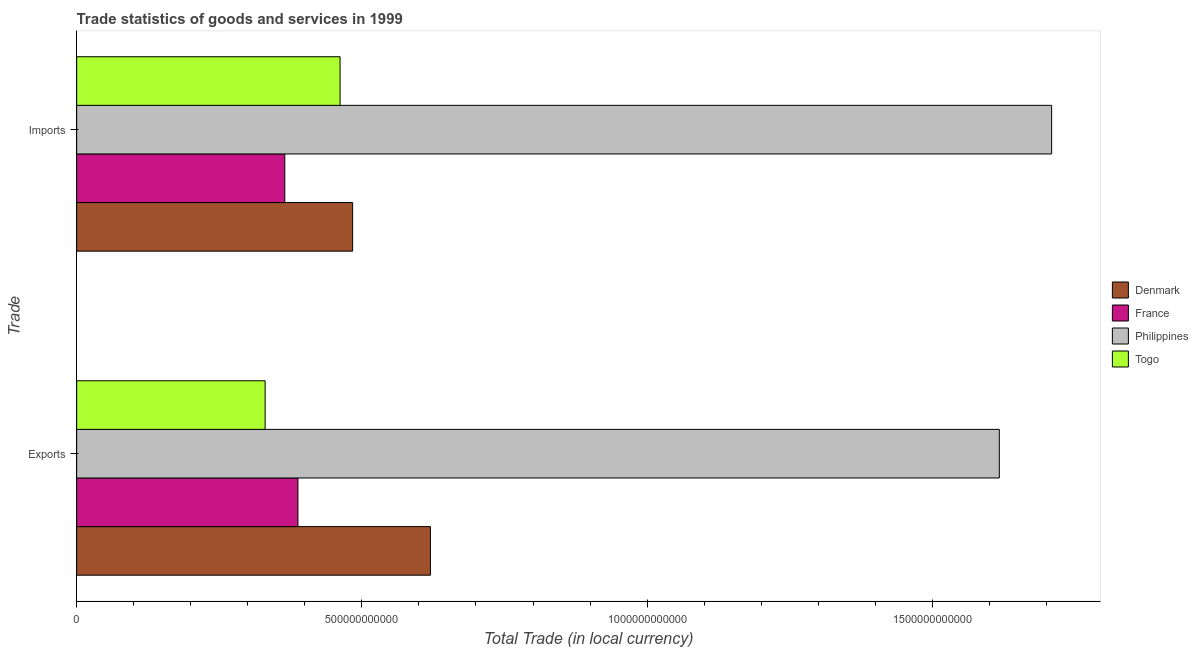Are the number of bars per tick equal to the number of legend labels?
Make the answer very short. Yes. What is the label of the 1st group of bars from the top?
Provide a succinct answer. Imports. What is the export of goods and services in Denmark?
Offer a very short reply. 6.20e+11. Across all countries, what is the maximum export of goods and services?
Provide a short and direct response. 1.62e+12. Across all countries, what is the minimum export of goods and services?
Offer a very short reply. 3.30e+11. In which country was the export of goods and services minimum?
Give a very brief answer. Togo. What is the total imports of goods and services in the graph?
Provide a short and direct response. 3.02e+12. What is the difference between the export of goods and services in Togo and that in Philippines?
Offer a terse response. -1.29e+12. What is the difference between the export of goods and services in Togo and the imports of goods and services in France?
Your response must be concise. -3.45e+1. What is the average export of goods and services per country?
Offer a very short reply. 7.39e+11. What is the difference between the export of goods and services and imports of goods and services in Philippines?
Your answer should be compact. -9.17e+1. In how many countries, is the export of goods and services greater than 800000000000 LCU?
Your answer should be compact. 1. What is the ratio of the imports of goods and services in Philippines to that in France?
Your answer should be very brief. 4.68. What does the 2nd bar from the top in Imports represents?
Offer a very short reply. Philippines. What does the 3rd bar from the bottom in Exports represents?
Give a very brief answer. Philippines. What is the difference between two consecutive major ticks on the X-axis?
Keep it short and to the point. 5.00e+11. Does the graph contain grids?
Make the answer very short. No. How are the legend labels stacked?
Give a very brief answer. Vertical. What is the title of the graph?
Provide a succinct answer. Trade statistics of goods and services in 1999. Does "Equatorial Guinea" appear as one of the legend labels in the graph?
Your answer should be very brief. No. What is the label or title of the X-axis?
Ensure brevity in your answer.  Total Trade (in local currency). What is the label or title of the Y-axis?
Your answer should be very brief. Trade. What is the Total Trade (in local currency) of Denmark in Exports?
Your answer should be very brief. 6.20e+11. What is the Total Trade (in local currency) in France in Exports?
Your response must be concise. 3.88e+11. What is the Total Trade (in local currency) in Philippines in Exports?
Give a very brief answer. 1.62e+12. What is the Total Trade (in local currency) in Togo in Exports?
Offer a terse response. 3.30e+11. What is the Total Trade (in local currency) of Denmark in Imports?
Make the answer very short. 4.84e+11. What is the Total Trade (in local currency) of France in Imports?
Provide a short and direct response. 3.65e+11. What is the Total Trade (in local currency) in Philippines in Imports?
Ensure brevity in your answer.  1.71e+12. What is the Total Trade (in local currency) of Togo in Imports?
Ensure brevity in your answer.  4.62e+11. Across all Trade, what is the maximum Total Trade (in local currency) of Denmark?
Ensure brevity in your answer.  6.20e+11. Across all Trade, what is the maximum Total Trade (in local currency) in France?
Give a very brief answer. 3.88e+11. Across all Trade, what is the maximum Total Trade (in local currency) in Philippines?
Your answer should be compact. 1.71e+12. Across all Trade, what is the maximum Total Trade (in local currency) of Togo?
Give a very brief answer. 4.62e+11. Across all Trade, what is the minimum Total Trade (in local currency) in Denmark?
Provide a succinct answer. 4.84e+11. Across all Trade, what is the minimum Total Trade (in local currency) in France?
Offer a very short reply. 3.65e+11. Across all Trade, what is the minimum Total Trade (in local currency) in Philippines?
Your answer should be very brief. 1.62e+12. Across all Trade, what is the minimum Total Trade (in local currency) in Togo?
Offer a very short reply. 3.30e+11. What is the total Total Trade (in local currency) of Denmark in the graph?
Offer a very short reply. 1.10e+12. What is the total Total Trade (in local currency) of France in the graph?
Provide a short and direct response. 7.53e+11. What is the total Total Trade (in local currency) in Philippines in the graph?
Make the answer very short. 3.33e+12. What is the total Total Trade (in local currency) in Togo in the graph?
Your answer should be compact. 7.92e+11. What is the difference between the Total Trade (in local currency) of Denmark in Exports and that in Imports?
Give a very brief answer. 1.36e+11. What is the difference between the Total Trade (in local currency) of France in Exports and that in Imports?
Provide a succinct answer. 2.30e+1. What is the difference between the Total Trade (in local currency) in Philippines in Exports and that in Imports?
Your response must be concise. -9.17e+1. What is the difference between the Total Trade (in local currency) in Togo in Exports and that in Imports?
Offer a terse response. -1.31e+11. What is the difference between the Total Trade (in local currency) of Denmark in Exports and the Total Trade (in local currency) of France in Imports?
Make the answer very short. 2.55e+11. What is the difference between the Total Trade (in local currency) of Denmark in Exports and the Total Trade (in local currency) of Philippines in Imports?
Ensure brevity in your answer.  -1.09e+12. What is the difference between the Total Trade (in local currency) of Denmark in Exports and the Total Trade (in local currency) of Togo in Imports?
Offer a very short reply. 1.58e+11. What is the difference between the Total Trade (in local currency) of France in Exports and the Total Trade (in local currency) of Philippines in Imports?
Provide a succinct answer. -1.32e+12. What is the difference between the Total Trade (in local currency) of France in Exports and the Total Trade (in local currency) of Togo in Imports?
Keep it short and to the point. -7.39e+1. What is the difference between the Total Trade (in local currency) of Philippines in Exports and the Total Trade (in local currency) of Togo in Imports?
Make the answer very short. 1.16e+12. What is the average Total Trade (in local currency) of Denmark per Trade?
Your response must be concise. 5.52e+11. What is the average Total Trade (in local currency) of France per Trade?
Keep it short and to the point. 3.76e+11. What is the average Total Trade (in local currency) in Philippines per Trade?
Offer a very short reply. 1.66e+12. What is the average Total Trade (in local currency) in Togo per Trade?
Ensure brevity in your answer.  3.96e+11. What is the difference between the Total Trade (in local currency) of Denmark and Total Trade (in local currency) of France in Exports?
Ensure brevity in your answer.  2.32e+11. What is the difference between the Total Trade (in local currency) of Denmark and Total Trade (in local currency) of Philippines in Exports?
Make the answer very short. -9.97e+11. What is the difference between the Total Trade (in local currency) in Denmark and Total Trade (in local currency) in Togo in Exports?
Make the answer very short. 2.90e+11. What is the difference between the Total Trade (in local currency) in France and Total Trade (in local currency) in Philippines in Exports?
Make the answer very short. -1.23e+12. What is the difference between the Total Trade (in local currency) of France and Total Trade (in local currency) of Togo in Exports?
Make the answer very short. 5.75e+1. What is the difference between the Total Trade (in local currency) of Philippines and Total Trade (in local currency) of Togo in Exports?
Keep it short and to the point. 1.29e+12. What is the difference between the Total Trade (in local currency) in Denmark and Total Trade (in local currency) in France in Imports?
Provide a short and direct response. 1.19e+11. What is the difference between the Total Trade (in local currency) in Denmark and Total Trade (in local currency) in Philippines in Imports?
Your answer should be compact. -1.23e+12. What is the difference between the Total Trade (in local currency) of Denmark and Total Trade (in local currency) of Togo in Imports?
Your answer should be compact. 2.20e+1. What is the difference between the Total Trade (in local currency) of France and Total Trade (in local currency) of Philippines in Imports?
Offer a terse response. -1.34e+12. What is the difference between the Total Trade (in local currency) in France and Total Trade (in local currency) in Togo in Imports?
Give a very brief answer. -9.69e+1. What is the difference between the Total Trade (in local currency) of Philippines and Total Trade (in local currency) of Togo in Imports?
Your response must be concise. 1.25e+12. What is the ratio of the Total Trade (in local currency) in Denmark in Exports to that in Imports?
Your response must be concise. 1.28. What is the ratio of the Total Trade (in local currency) in France in Exports to that in Imports?
Keep it short and to the point. 1.06. What is the ratio of the Total Trade (in local currency) in Philippines in Exports to that in Imports?
Your response must be concise. 0.95. What is the ratio of the Total Trade (in local currency) of Togo in Exports to that in Imports?
Provide a succinct answer. 0.72. What is the difference between the highest and the second highest Total Trade (in local currency) of Denmark?
Ensure brevity in your answer.  1.36e+11. What is the difference between the highest and the second highest Total Trade (in local currency) of France?
Offer a very short reply. 2.30e+1. What is the difference between the highest and the second highest Total Trade (in local currency) in Philippines?
Provide a succinct answer. 9.17e+1. What is the difference between the highest and the second highest Total Trade (in local currency) of Togo?
Your answer should be very brief. 1.31e+11. What is the difference between the highest and the lowest Total Trade (in local currency) in Denmark?
Your answer should be compact. 1.36e+11. What is the difference between the highest and the lowest Total Trade (in local currency) of France?
Offer a terse response. 2.30e+1. What is the difference between the highest and the lowest Total Trade (in local currency) of Philippines?
Your answer should be very brief. 9.17e+1. What is the difference between the highest and the lowest Total Trade (in local currency) of Togo?
Provide a succinct answer. 1.31e+11. 